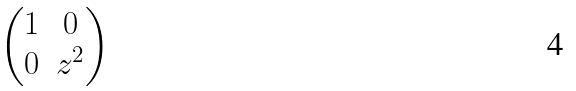Convert formula to latex. <formula><loc_0><loc_0><loc_500><loc_500>\begin{pmatrix} 1 & 0 \\ 0 & z ^ { 2 } \end{pmatrix}</formula> 